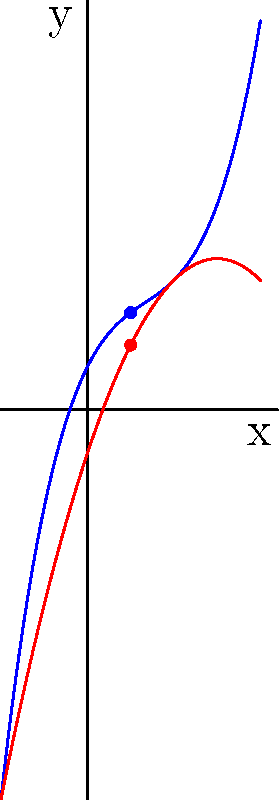As a photojournalist documenting a research project on polynomial functions, you've captured an image of two graphs representing different rates of change. The blue curve represents $f(x) = 0.25x^3 - x^2 + 2x + 1$, and the red curve represents $g(x) = -0.5x^2 + 3x - 1$. At $x = 1$, which function has a greater rate of change, and by how much? To determine which function has a greater rate of change at $x = 1$, we need to compare their derivatives at this point:

1) For $f(x) = 0.25x^3 - x^2 + 2x + 1$:
   $f'(x) = 0.75x^2 - 2x + 2$
   At $x = 1$: $f'(1) = 0.75(1)^2 - 2(1) + 2 = 0.75$

2) For $g(x) = -0.5x^2 + 3x - 1$:
   $g'(x) = -x + 3$
   At $x = 1$: $g'(1) = -1 + 3 = 2$

3) Compare the rates of change:
   $g'(1) = 2$ is greater than $f'(1) = 0.75$

4) Calculate the difference:
   $2 - 0.75 = 1.25$

Therefore, at $x = 1$, $g(x)$ has a greater rate of change than $f(x)$ by 1.25 units.
Answer: $g(x)$, by 1.25 units 